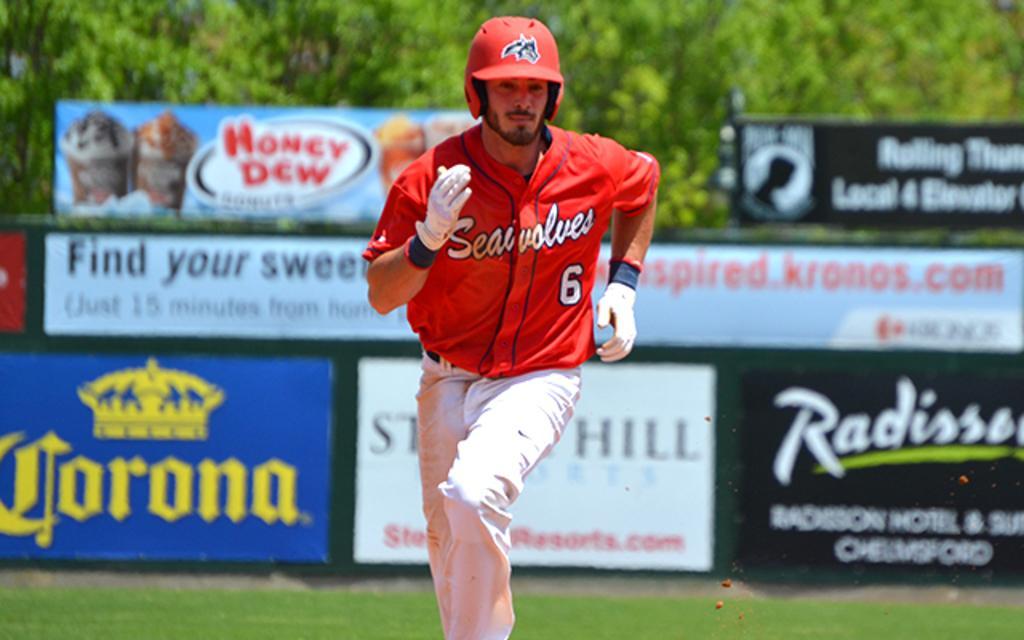In one or two sentences, can you explain what this image depicts? In this image, at the middle we can see a man running, he is wearing a red color helmet, in the background we can see some posters and there are some green color trees. 